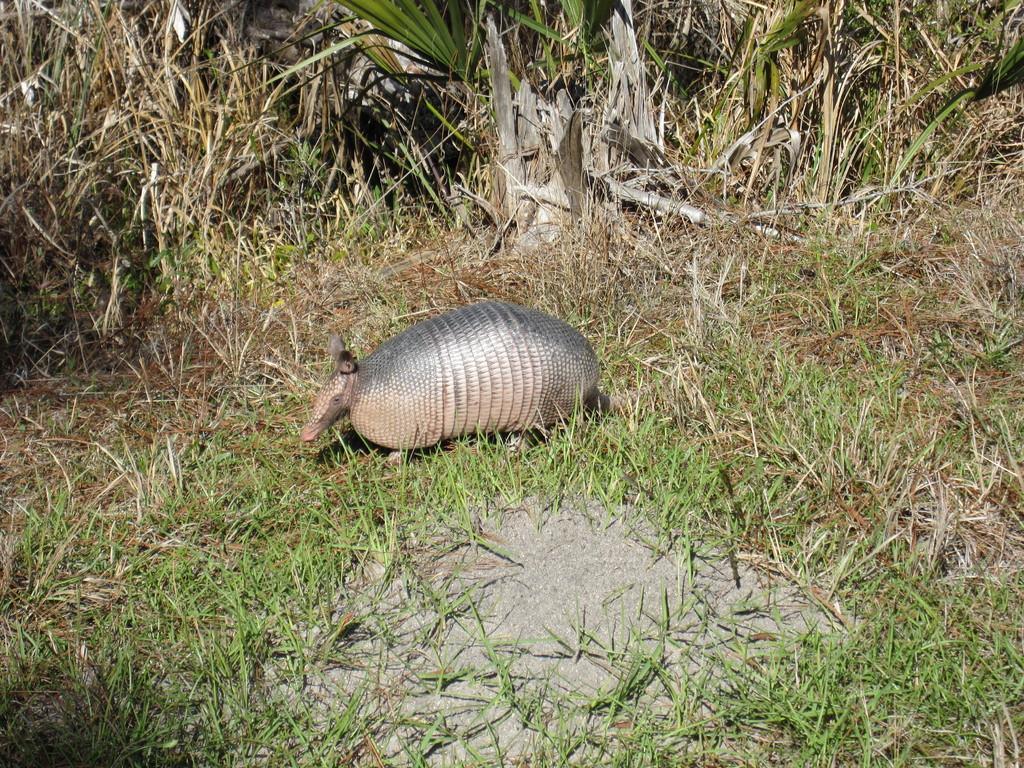Please provide a concise description of this image. In this image, we can see an animal on the grass and there are some plants. 